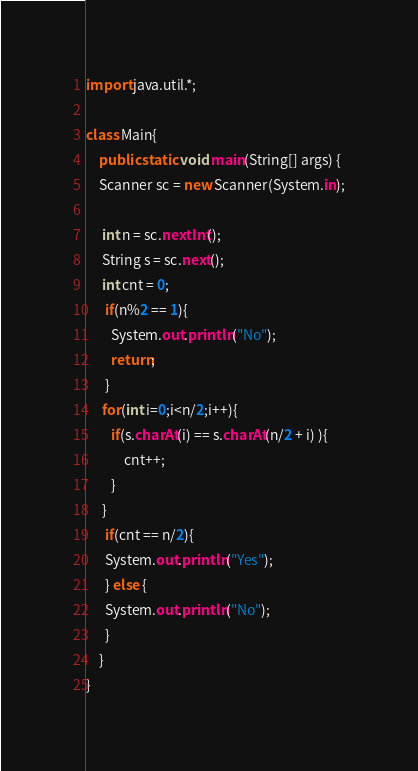<code> <loc_0><loc_0><loc_500><loc_500><_Java_>import java.util.*;

class Main{
	public static void main(String[] args) {
    Scanner sc = new Scanner(System.in);
    
     int n = sc.nextInt();
     String s = sc.next();
     int cnt = 0;
      if(n%2 == 1){
      	System.out.println("No");
        return;
      }
     for(int i=0;i<n/2;i++){
     	if(s.charAt(i) == s.charAt(n/2 + i) ){
        	cnt++;
        }
     } 
      if(cnt == n/2){
      System.out.println("Yes");
      } else {
      System.out.println("No");
      }
	}
}</code> 